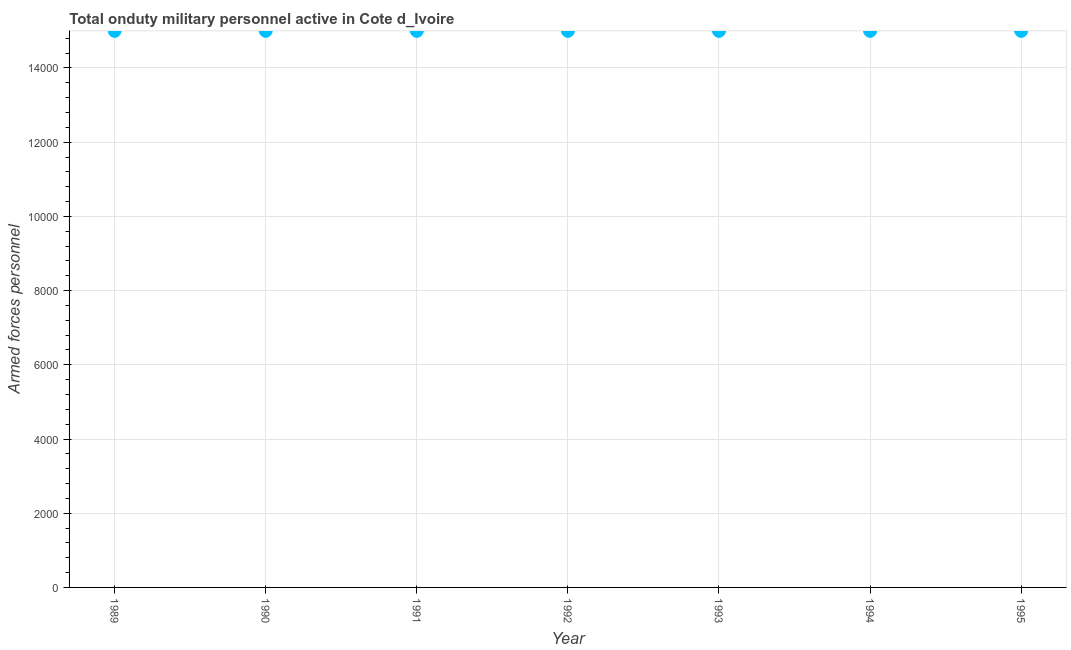What is the number of armed forces personnel in 1990?
Your response must be concise. 1.50e+04. Across all years, what is the maximum number of armed forces personnel?
Provide a succinct answer. 1.50e+04. Across all years, what is the minimum number of armed forces personnel?
Provide a succinct answer. 1.50e+04. What is the sum of the number of armed forces personnel?
Your response must be concise. 1.05e+05. What is the average number of armed forces personnel per year?
Your answer should be very brief. 1.50e+04. What is the median number of armed forces personnel?
Your response must be concise. 1.50e+04. Do a majority of the years between 1992 and 1994 (inclusive) have number of armed forces personnel greater than 6000 ?
Offer a terse response. Yes. What is the ratio of the number of armed forces personnel in 1992 to that in 1995?
Offer a very short reply. 1. Is the difference between the number of armed forces personnel in 1989 and 1990 greater than the difference between any two years?
Ensure brevity in your answer.  Yes. In how many years, is the number of armed forces personnel greater than the average number of armed forces personnel taken over all years?
Make the answer very short. 0. Does the number of armed forces personnel monotonically increase over the years?
Offer a terse response. No. How many dotlines are there?
Give a very brief answer. 1. What is the difference between two consecutive major ticks on the Y-axis?
Offer a very short reply. 2000. Are the values on the major ticks of Y-axis written in scientific E-notation?
Your answer should be very brief. No. What is the title of the graph?
Provide a short and direct response. Total onduty military personnel active in Cote d_Ivoire. What is the label or title of the Y-axis?
Keep it short and to the point. Armed forces personnel. What is the Armed forces personnel in 1989?
Provide a short and direct response. 1.50e+04. What is the Armed forces personnel in 1990?
Ensure brevity in your answer.  1.50e+04. What is the Armed forces personnel in 1991?
Your answer should be very brief. 1.50e+04. What is the Armed forces personnel in 1992?
Offer a very short reply. 1.50e+04. What is the Armed forces personnel in 1993?
Offer a very short reply. 1.50e+04. What is the Armed forces personnel in 1994?
Provide a short and direct response. 1.50e+04. What is the Armed forces personnel in 1995?
Make the answer very short. 1.50e+04. What is the difference between the Armed forces personnel in 1989 and 1995?
Your answer should be compact. 0. What is the difference between the Armed forces personnel in 1990 and 1991?
Give a very brief answer. 0. What is the difference between the Armed forces personnel in 1990 and 1993?
Provide a short and direct response. 0. What is the difference between the Armed forces personnel in 1990 and 1995?
Your answer should be very brief. 0. What is the difference between the Armed forces personnel in 1991 and 1994?
Ensure brevity in your answer.  0. What is the difference between the Armed forces personnel in 1992 and 1995?
Offer a very short reply. 0. What is the difference between the Armed forces personnel in 1993 and 1994?
Give a very brief answer. 0. What is the difference between the Armed forces personnel in 1993 and 1995?
Give a very brief answer. 0. What is the difference between the Armed forces personnel in 1994 and 1995?
Your answer should be compact. 0. What is the ratio of the Armed forces personnel in 1989 to that in 1990?
Your answer should be compact. 1. What is the ratio of the Armed forces personnel in 1989 to that in 1991?
Your answer should be very brief. 1. What is the ratio of the Armed forces personnel in 1989 to that in 1993?
Offer a terse response. 1. What is the ratio of the Armed forces personnel in 1990 to that in 1991?
Your answer should be compact. 1. What is the ratio of the Armed forces personnel in 1991 to that in 1992?
Offer a terse response. 1. What is the ratio of the Armed forces personnel in 1991 to that in 1993?
Give a very brief answer. 1. What is the ratio of the Armed forces personnel in 1991 to that in 1995?
Provide a short and direct response. 1. What is the ratio of the Armed forces personnel in 1992 to that in 1995?
Keep it short and to the point. 1. What is the ratio of the Armed forces personnel in 1994 to that in 1995?
Keep it short and to the point. 1. 